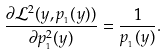Convert formula to latex. <formula><loc_0><loc_0><loc_500><loc_500>\frac { \partial \mathcal { L } ^ { 2 } ( y , p _ { _ { 1 } } ( y ) ) } { \partial p _ { _ { 1 } } ^ { 2 } ( y ) } = \frac { 1 } { p _ { _ { 1 } } ( y ) } .</formula> 